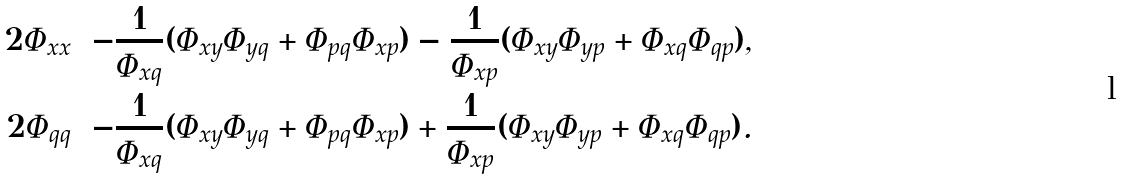Convert formula to latex. <formula><loc_0><loc_0><loc_500><loc_500>2 \Phi _ { x x } & = - \frac { 1 } { \Phi _ { x q } } ( \Phi _ { x y } \Phi _ { y q } + \Phi _ { p q } \Phi _ { x p } ) - \frac { 1 } { \Phi _ { x p } } ( \Phi _ { x y } \Phi _ { y p } + \Phi _ { x q } \Phi _ { q p } ) , \\ 2 \Phi _ { q q } & = - \frac { 1 } { \Phi _ { x q } } ( \Phi _ { x y } \Phi _ { y q } + \Phi _ { p q } \Phi _ { x p } ) + \frac { 1 } { \Phi _ { x p } } ( \Phi _ { x y } \Phi _ { y p } + \Phi _ { x q } \Phi _ { q p } ) .</formula> 